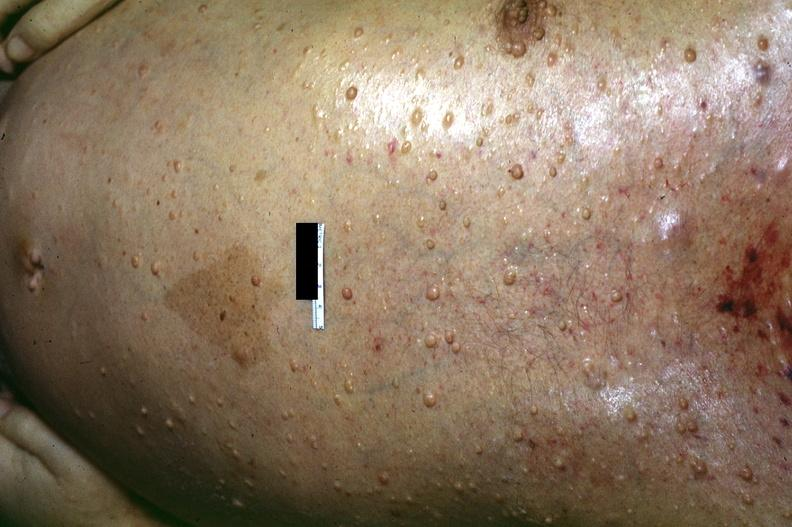what does this image show?
Answer the question using a single word or phrase. Skin 